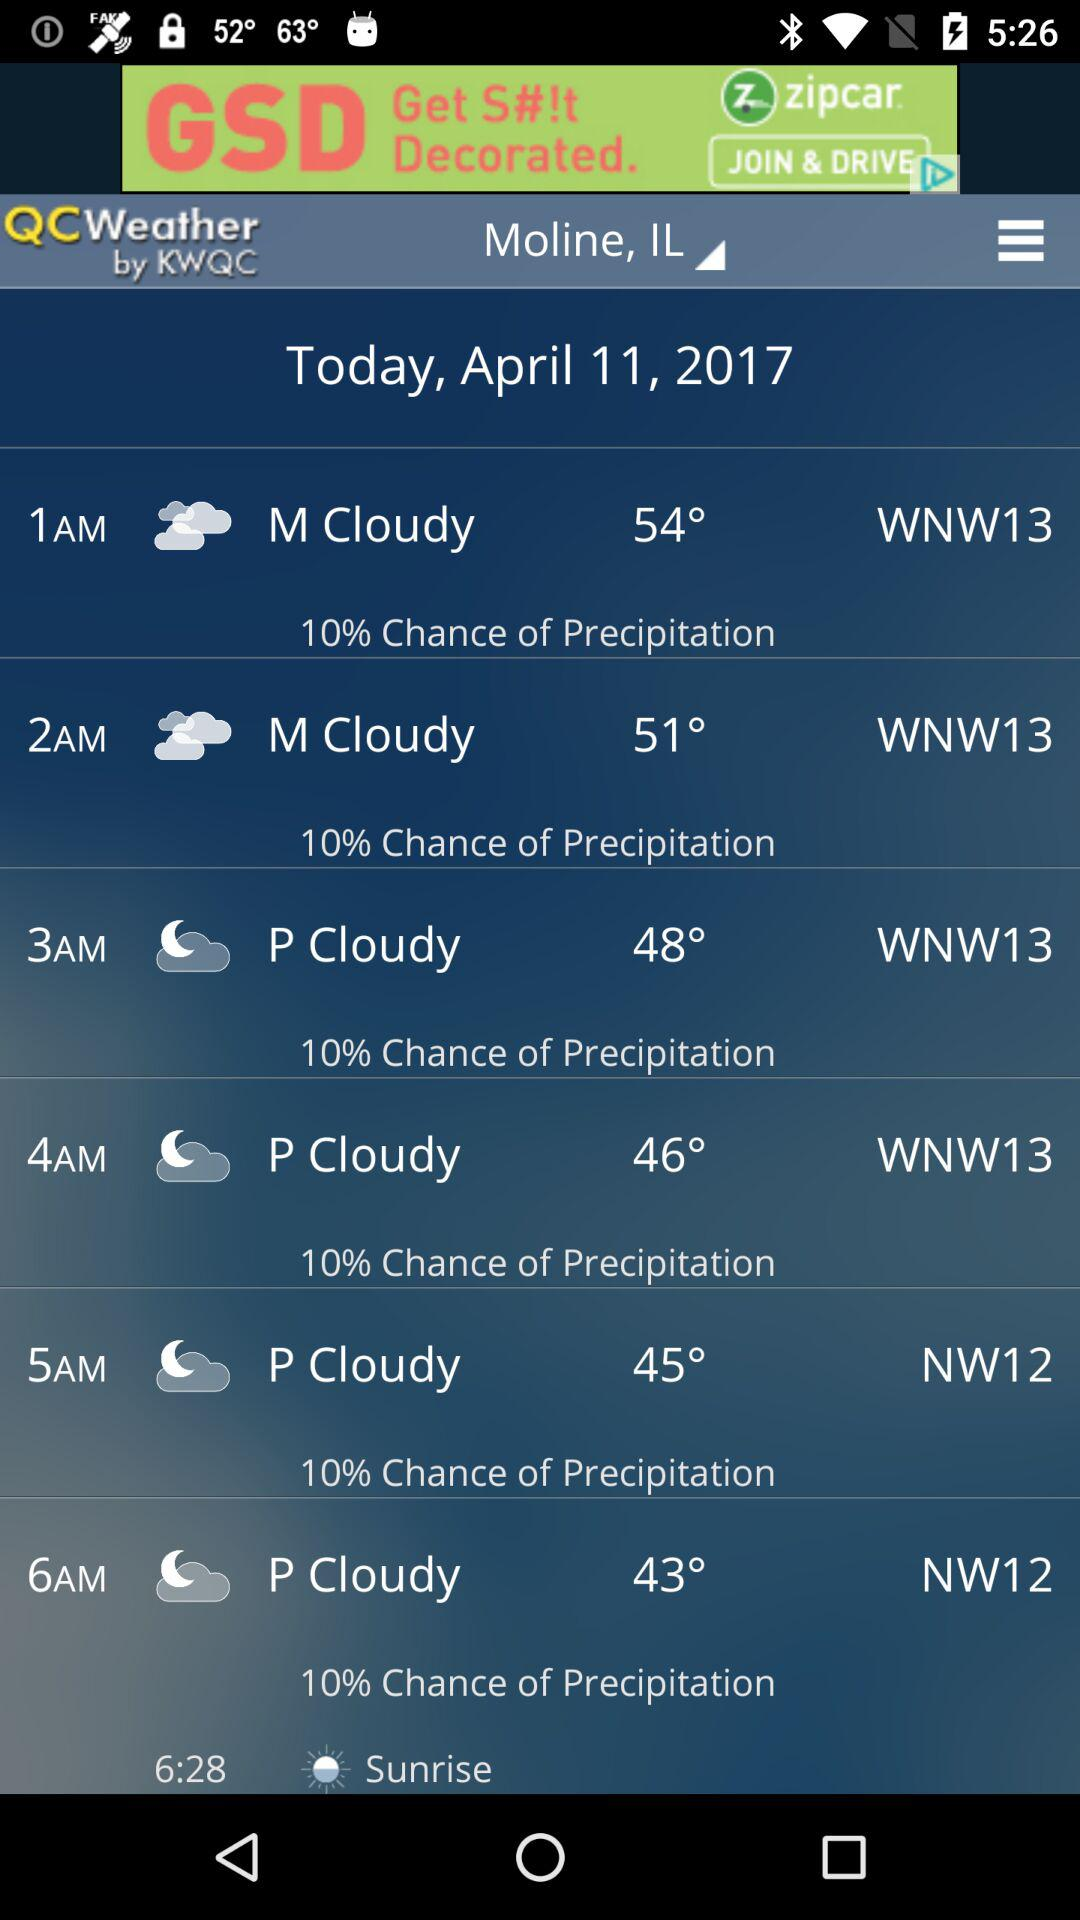What is the probability of precipitation in the next 6 hours?
Answer the question using a single word or phrase. 10% 